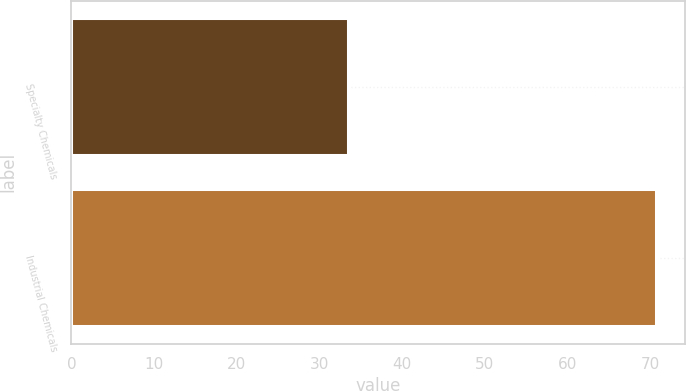Convert chart. <chart><loc_0><loc_0><loc_500><loc_500><bar_chart><fcel>Specialty Chemicals<fcel>Industrial Chemicals<nl><fcel>33.5<fcel>70.7<nl></chart> 